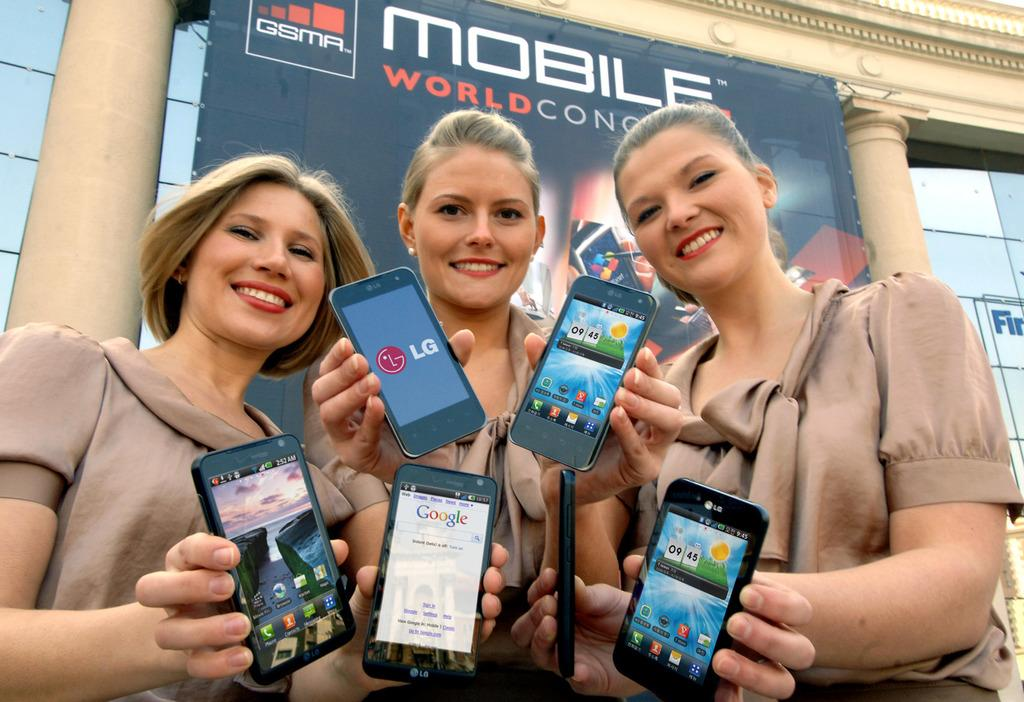Provide a one-sentence caption for the provided image. Three women holding cell phones in front of a sign that reads Mobile World Congress. 